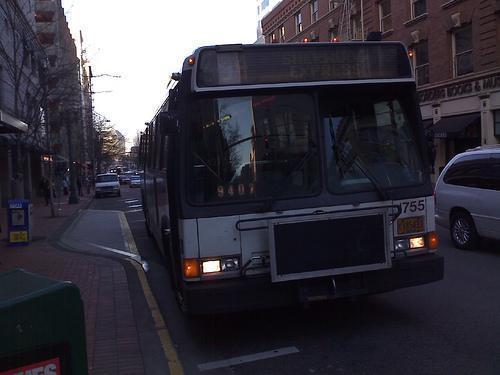How many blue cars are seen in this picture?
Give a very brief answer. 0. How many animals appear pictured here?
Give a very brief answer. 0. How many buses are in this picture?
Give a very brief answer. 1. 